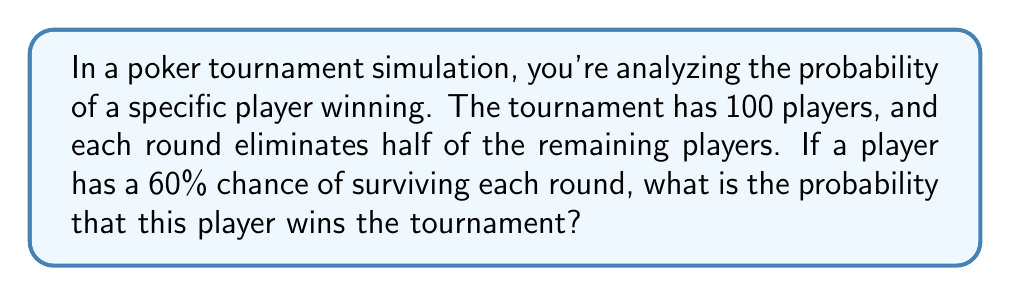Provide a solution to this math problem. Let's approach this step-by-step:

1) First, we need to determine how many rounds the tournament will have. With 100 players and half being eliminated each round:
   Round 1: 100 → 50
   Round 2: 50 → 25
   Round 3: 25 → 12.5 (rounded up to 13)
   Round 4: 13 → 6.5 (rounded up to 7)
   Round 5: 7 → 3.5 (rounded up to 4)
   Round 6: 4 → 2
   Round 7: 2 → 1 (winner)

   So, there are 7 rounds in total.

2) The probability of the player surviving all 7 rounds is:
   $$(0.60)^7$$

3) However, surviving isn't enough to win. The player must be the last one standing. The probability of being the winner, given that they've survived all rounds, is $\frac{1}{n}$ where $n$ is the number of survivors in the final round. In this case, $n = 2$.

4) Therefore, the probability of winning is:
   $$P(\text{win}) = (0.60)^7 \cdot \frac{1}{2}$$

5) Let's calculate this:
   $$P(\text{win}) = (0.60)^7 \cdot \frac{1}{2} = 0.0279 \cdot 0.5 = 0.01395$$

6) Converting to a percentage:
   $$0.01395 \cdot 100\% = 1.395\%$$
Answer: 1.395% 